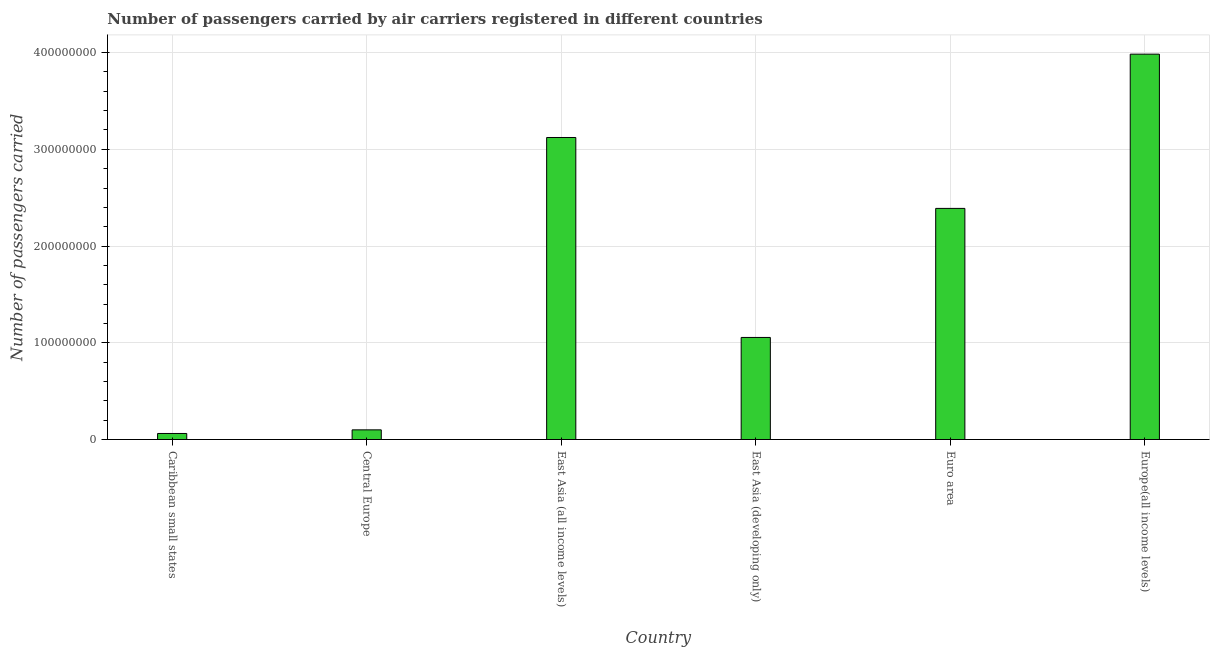Does the graph contain grids?
Keep it short and to the point. Yes. What is the title of the graph?
Your answer should be very brief. Number of passengers carried by air carriers registered in different countries. What is the label or title of the Y-axis?
Offer a terse response. Number of passengers carried. What is the number of passengers carried in East Asia (developing only)?
Offer a terse response. 1.06e+08. Across all countries, what is the maximum number of passengers carried?
Make the answer very short. 3.98e+08. Across all countries, what is the minimum number of passengers carried?
Make the answer very short. 6.25e+06. In which country was the number of passengers carried maximum?
Provide a succinct answer. Europe(all income levels). In which country was the number of passengers carried minimum?
Your answer should be compact. Caribbean small states. What is the sum of the number of passengers carried?
Offer a very short reply. 1.07e+09. What is the difference between the number of passengers carried in East Asia (developing only) and Euro area?
Your response must be concise. -1.33e+08. What is the average number of passengers carried per country?
Give a very brief answer. 1.79e+08. What is the median number of passengers carried?
Make the answer very short. 1.72e+08. What is the ratio of the number of passengers carried in Caribbean small states to that in East Asia (developing only)?
Give a very brief answer. 0.06. Is the difference between the number of passengers carried in East Asia (developing only) and Euro area greater than the difference between any two countries?
Your answer should be compact. No. What is the difference between the highest and the second highest number of passengers carried?
Your answer should be very brief. 8.62e+07. What is the difference between the highest and the lowest number of passengers carried?
Your answer should be compact. 3.92e+08. How many bars are there?
Offer a terse response. 6. Are the values on the major ticks of Y-axis written in scientific E-notation?
Make the answer very short. No. What is the Number of passengers carried of Caribbean small states?
Your answer should be compact. 6.25e+06. What is the Number of passengers carried in Central Europe?
Ensure brevity in your answer.  9.99e+06. What is the Number of passengers carried of East Asia (all income levels)?
Give a very brief answer. 3.12e+08. What is the Number of passengers carried in East Asia (developing only)?
Provide a succinct answer. 1.06e+08. What is the Number of passengers carried in Euro area?
Your answer should be very brief. 2.39e+08. What is the Number of passengers carried in Europe(all income levels)?
Your answer should be very brief. 3.98e+08. What is the difference between the Number of passengers carried in Caribbean small states and Central Europe?
Give a very brief answer. -3.74e+06. What is the difference between the Number of passengers carried in Caribbean small states and East Asia (all income levels)?
Make the answer very short. -3.06e+08. What is the difference between the Number of passengers carried in Caribbean small states and East Asia (developing only)?
Give a very brief answer. -9.93e+07. What is the difference between the Number of passengers carried in Caribbean small states and Euro area?
Offer a terse response. -2.33e+08. What is the difference between the Number of passengers carried in Caribbean small states and Europe(all income levels)?
Offer a terse response. -3.92e+08. What is the difference between the Number of passengers carried in Central Europe and East Asia (all income levels)?
Ensure brevity in your answer.  -3.02e+08. What is the difference between the Number of passengers carried in Central Europe and East Asia (developing only)?
Your response must be concise. -9.55e+07. What is the difference between the Number of passengers carried in Central Europe and Euro area?
Offer a terse response. -2.29e+08. What is the difference between the Number of passengers carried in Central Europe and Europe(all income levels)?
Make the answer very short. -3.88e+08. What is the difference between the Number of passengers carried in East Asia (all income levels) and East Asia (developing only)?
Provide a succinct answer. 2.07e+08. What is the difference between the Number of passengers carried in East Asia (all income levels) and Euro area?
Your answer should be compact. 7.33e+07. What is the difference between the Number of passengers carried in East Asia (all income levels) and Europe(all income levels)?
Provide a short and direct response. -8.62e+07. What is the difference between the Number of passengers carried in East Asia (developing only) and Euro area?
Offer a terse response. -1.33e+08. What is the difference between the Number of passengers carried in East Asia (developing only) and Europe(all income levels)?
Your response must be concise. -2.93e+08. What is the difference between the Number of passengers carried in Euro area and Europe(all income levels)?
Your response must be concise. -1.59e+08. What is the ratio of the Number of passengers carried in Caribbean small states to that in Central Europe?
Your answer should be compact. 0.63. What is the ratio of the Number of passengers carried in Caribbean small states to that in East Asia (developing only)?
Keep it short and to the point. 0.06. What is the ratio of the Number of passengers carried in Caribbean small states to that in Euro area?
Provide a succinct answer. 0.03. What is the ratio of the Number of passengers carried in Caribbean small states to that in Europe(all income levels)?
Give a very brief answer. 0.02. What is the ratio of the Number of passengers carried in Central Europe to that in East Asia (all income levels)?
Your answer should be very brief. 0.03. What is the ratio of the Number of passengers carried in Central Europe to that in East Asia (developing only)?
Your answer should be very brief. 0.1. What is the ratio of the Number of passengers carried in Central Europe to that in Euro area?
Offer a terse response. 0.04. What is the ratio of the Number of passengers carried in Central Europe to that in Europe(all income levels)?
Your answer should be compact. 0.03. What is the ratio of the Number of passengers carried in East Asia (all income levels) to that in East Asia (developing only)?
Give a very brief answer. 2.96. What is the ratio of the Number of passengers carried in East Asia (all income levels) to that in Euro area?
Give a very brief answer. 1.31. What is the ratio of the Number of passengers carried in East Asia (all income levels) to that in Europe(all income levels)?
Provide a succinct answer. 0.78. What is the ratio of the Number of passengers carried in East Asia (developing only) to that in Euro area?
Your answer should be very brief. 0.44. What is the ratio of the Number of passengers carried in East Asia (developing only) to that in Europe(all income levels)?
Ensure brevity in your answer.  0.27. What is the ratio of the Number of passengers carried in Euro area to that in Europe(all income levels)?
Offer a terse response. 0.6. 